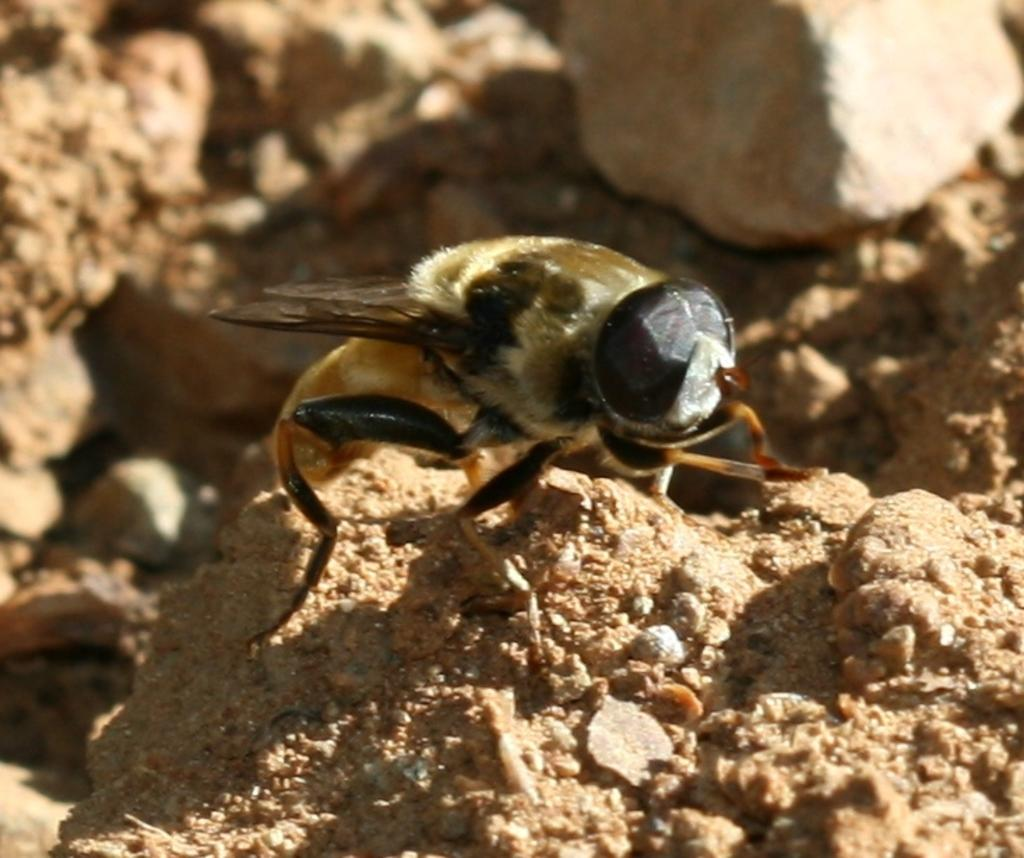What type of creature can be seen in the image? There is an insect in the image. What can be seen in the background of the image? There are stones visible in the background of the image. What type of ear is visible in the image? There is no ear present in the image; it features an insect and stones in the background. 